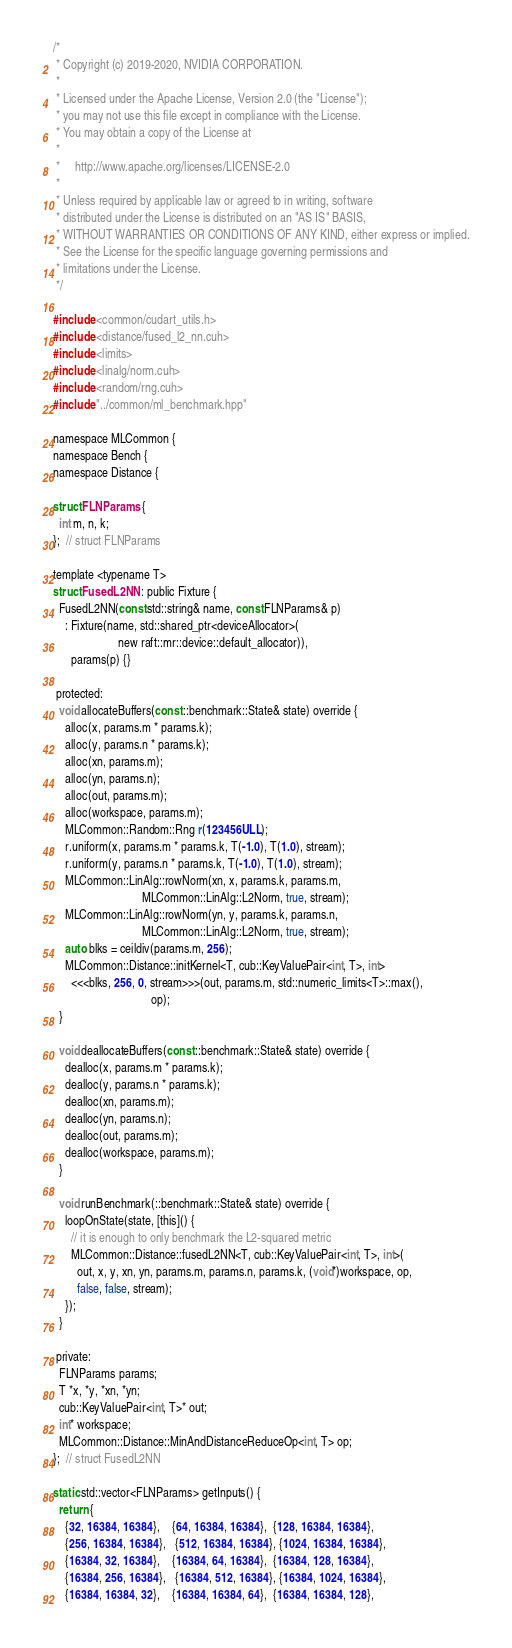Convert code to text. <code><loc_0><loc_0><loc_500><loc_500><_Cuda_>/*
 * Copyright (c) 2019-2020, NVIDIA CORPORATION.
 *
 * Licensed under the Apache License, Version 2.0 (the "License");
 * you may not use this file except in compliance with the License.
 * You may obtain a copy of the License at
 *
 *     http://www.apache.org/licenses/LICENSE-2.0
 *
 * Unless required by applicable law or agreed to in writing, software
 * distributed under the License is distributed on an "AS IS" BASIS,
 * WITHOUT WARRANTIES OR CONDITIONS OF ANY KIND, either express or implied.
 * See the License for the specific language governing permissions and
 * limitations under the License.
 */

#include <common/cudart_utils.h>
#include <distance/fused_l2_nn.cuh>
#include <limits>
#include <linalg/norm.cuh>
#include <random/rng.cuh>
#include "../common/ml_benchmark.hpp"

namespace MLCommon {
namespace Bench {
namespace Distance {

struct FLNParams {
  int m, n, k;
};  // struct FLNParams

template <typename T>
struct FusedL2NN : public Fixture {
  FusedL2NN(const std::string& name, const FLNParams& p)
    : Fixture(name, std::shared_ptr<deviceAllocator>(
                      new raft::mr::device::default_allocator)),
      params(p) {}

 protected:
  void allocateBuffers(const ::benchmark::State& state) override {
    alloc(x, params.m * params.k);
    alloc(y, params.n * params.k);
    alloc(xn, params.m);
    alloc(yn, params.n);
    alloc(out, params.m);
    alloc(workspace, params.m);
    MLCommon::Random::Rng r(123456ULL);
    r.uniform(x, params.m * params.k, T(-1.0), T(1.0), stream);
    r.uniform(y, params.n * params.k, T(-1.0), T(1.0), stream);
    MLCommon::LinAlg::rowNorm(xn, x, params.k, params.m,
                              MLCommon::LinAlg::L2Norm, true, stream);
    MLCommon::LinAlg::rowNorm(yn, y, params.k, params.n,
                              MLCommon::LinAlg::L2Norm, true, stream);
    auto blks = ceildiv(params.m, 256);
    MLCommon::Distance::initKernel<T, cub::KeyValuePair<int, T>, int>
      <<<blks, 256, 0, stream>>>(out, params.m, std::numeric_limits<T>::max(),
                                 op);
  }

  void deallocateBuffers(const ::benchmark::State& state) override {
    dealloc(x, params.m * params.k);
    dealloc(y, params.n * params.k);
    dealloc(xn, params.m);
    dealloc(yn, params.n);
    dealloc(out, params.m);
    dealloc(workspace, params.m);
  }

  void runBenchmark(::benchmark::State& state) override {
    loopOnState(state, [this]() {
      // it is enough to only benchmark the L2-squared metric
      MLCommon::Distance::fusedL2NN<T, cub::KeyValuePair<int, T>, int>(
        out, x, y, xn, yn, params.m, params.n, params.k, (void*)workspace, op,
        false, false, stream);
    });
  }

 private:
  FLNParams params;
  T *x, *y, *xn, *yn;
  cub::KeyValuePair<int, T>* out;
  int* workspace;
  MLCommon::Distance::MinAndDistanceReduceOp<int, T> op;
};  // struct FusedL2NN

static std::vector<FLNParams> getInputs() {
  return {
    {32, 16384, 16384},    {64, 16384, 16384},  {128, 16384, 16384},
    {256, 16384, 16384},   {512, 16384, 16384}, {1024, 16384, 16384},
    {16384, 32, 16384},    {16384, 64, 16384},  {16384, 128, 16384},
    {16384, 256, 16384},   {16384, 512, 16384}, {16384, 1024, 16384},
    {16384, 16384, 32},    {16384, 16384, 64},  {16384, 16384, 128},</code> 